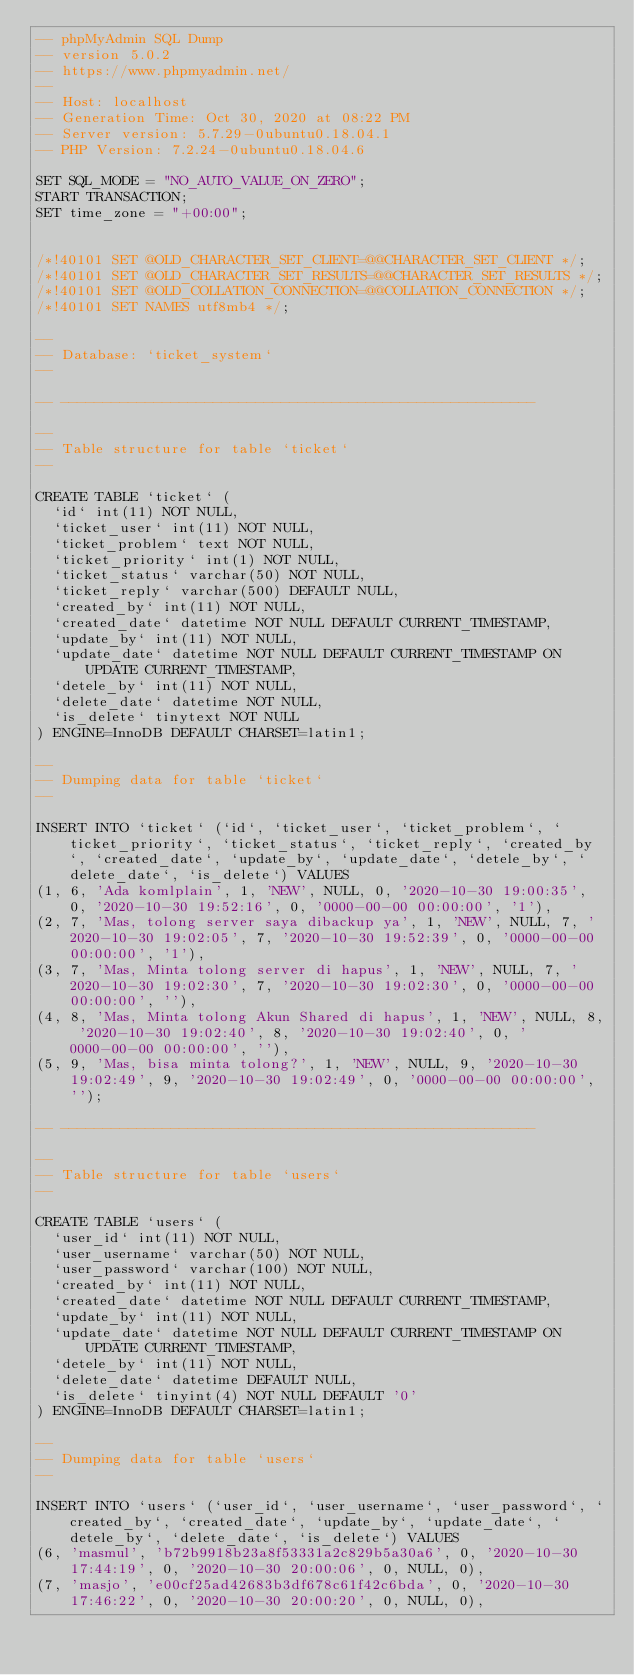<code> <loc_0><loc_0><loc_500><loc_500><_SQL_>-- phpMyAdmin SQL Dump
-- version 5.0.2
-- https://www.phpmyadmin.net/
--
-- Host: localhost
-- Generation Time: Oct 30, 2020 at 08:22 PM
-- Server version: 5.7.29-0ubuntu0.18.04.1
-- PHP Version: 7.2.24-0ubuntu0.18.04.6

SET SQL_MODE = "NO_AUTO_VALUE_ON_ZERO";
START TRANSACTION;
SET time_zone = "+00:00";


/*!40101 SET @OLD_CHARACTER_SET_CLIENT=@@CHARACTER_SET_CLIENT */;
/*!40101 SET @OLD_CHARACTER_SET_RESULTS=@@CHARACTER_SET_RESULTS */;
/*!40101 SET @OLD_COLLATION_CONNECTION=@@COLLATION_CONNECTION */;
/*!40101 SET NAMES utf8mb4 */;

--
-- Database: `ticket_system`
--

-- --------------------------------------------------------

--
-- Table structure for table `ticket`
--

CREATE TABLE `ticket` (
  `id` int(11) NOT NULL,
  `ticket_user` int(11) NOT NULL,
  `ticket_problem` text NOT NULL,
  `ticket_priority` int(1) NOT NULL,
  `ticket_status` varchar(50) NOT NULL,
  `ticket_reply` varchar(500) DEFAULT NULL,
  `created_by` int(11) NOT NULL,
  `created_date` datetime NOT NULL DEFAULT CURRENT_TIMESTAMP,
  `update_by` int(11) NOT NULL,
  `update_date` datetime NOT NULL DEFAULT CURRENT_TIMESTAMP ON UPDATE CURRENT_TIMESTAMP,
  `detele_by` int(11) NOT NULL,
  `delete_date` datetime NOT NULL,
  `is_delete` tinytext NOT NULL
) ENGINE=InnoDB DEFAULT CHARSET=latin1;

--
-- Dumping data for table `ticket`
--

INSERT INTO `ticket` (`id`, `ticket_user`, `ticket_problem`, `ticket_priority`, `ticket_status`, `ticket_reply`, `created_by`, `created_date`, `update_by`, `update_date`, `detele_by`, `delete_date`, `is_delete`) VALUES
(1, 6, 'Ada komlplain', 1, 'NEW', NULL, 0, '2020-10-30 19:00:35', 0, '2020-10-30 19:52:16', 0, '0000-00-00 00:00:00', '1'),
(2, 7, 'Mas, tolong server saya dibackup ya', 1, 'NEW', NULL, 7, '2020-10-30 19:02:05', 7, '2020-10-30 19:52:39', 0, '0000-00-00 00:00:00', '1'),
(3, 7, 'Mas, Minta tolong server di hapus', 1, 'NEW', NULL, 7, '2020-10-30 19:02:30', 7, '2020-10-30 19:02:30', 0, '0000-00-00 00:00:00', ''),
(4, 8, 'Mas, Minta tolong Akun Shared di hapus', 1, 'NEW', NULL, 8, '2020-10-30 19:02:40', 8, '2020-10-30 19:02:40', 0, '0000-00-00 00:00:00', ''),
(5, 9, 'Mas, bisa minta tolong?', 1, 'NEW', NULL, 9, '2020-10-30 19:02:49', 9, '2020-10-30 19:02:49', 0, '0000-00-00 00:00:00', '');

-- --------------------------------------------------------

--
-- Table structure for table `users`
--

CREATE TABLE `users` (
  `user_id` int(11) NOT NULL,
  `user_username` varchar(50) NOT NULL,
  `user_password` varchar(100) NOT NULL,
  `created_by` int(11) NOT NULL,
  `created_date` datetime NOT NULL DEFAULT CURRENT_TIMESTAMP,
  `update_by` int(11) NOT NULL,
  `update_date` datetime NOT NULL DEFAULT CURRENT_TIMESTAMP ON UPDATE CURRENT_TIMESTAMP,
  `detele_by` int(11) NOT NULL,
  `delete_date` datetime DEFAULT NULL,
  `is_delete` tinyint(4) NOT NULL DEFAULT '0'
) ENGINE=InnoDB DEFAULT CHARSET=latin1;

--
-- Dumping data for table `users`
--

INSERT INTO `users` (`user_id`, `user_username`, `user_password`, `created_by`, `created_date`, `update_by`, `update_date`, `detele_by`, `delete_date`, `is_delete`) VALUES
(6, 'masmul', 'b72b9918b23a8f53331a2c829b5a30a6', 0, '2020-10-30 17:44:19', 0, '2020-10-30 20:00:06', 0, NULL, 0),
(7, 'masjo', 'e00cf25ad42683b3df678c61f42c6bda', 0, '2020-10-30 17:46:22', 0, '2020-10-30 20:00:20', 0, NULL, 0),</code> 